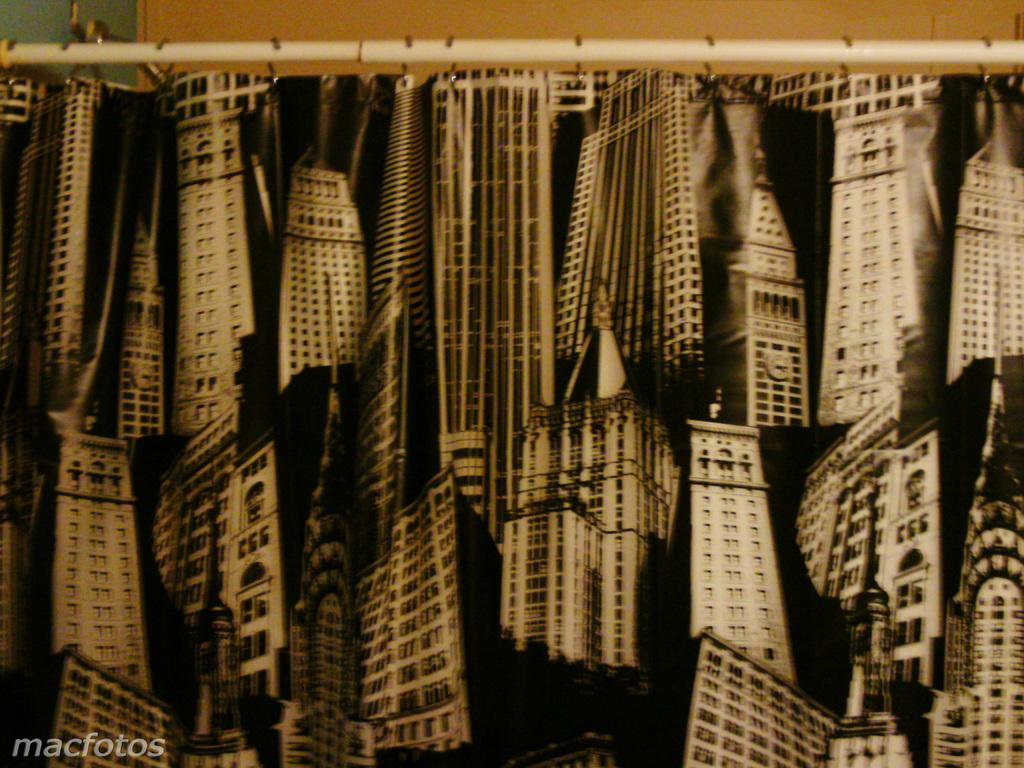What is located at the top of the image? There is a road at the top of the image. What can be seen attached to the road in the image? Posters are attached to the road in the image. What type of twig can be seen growing on the island in the image? There is no island or twig present in the image; it only features a road with posters attached to it. 